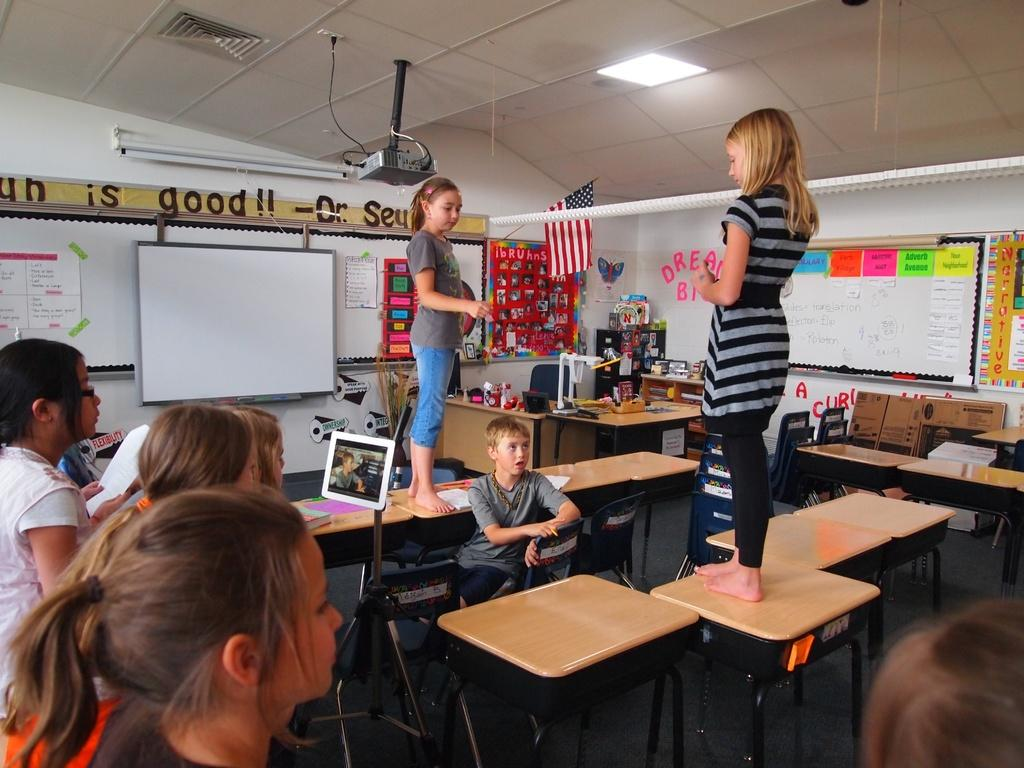What are the two girls doing in the image? The two girls are standing on a table in the image. Are there any other people present in the image? Yes, there are other people watching the girls in the image. What can be seen in the background of the image? There is a flag, a projector, a white screen, and a light in the image. What type of sign can be seen hanging from the ceiling in the image? There is no sign hanging from the ceiling in the image. How does the acoustics of the room affect the girls' performance in the image? The provided facts do not mention anything about the acoustics of the room, so it cannot be determined how it affects the girls' performance. Can you tell me how many pickles are on the table in the image? There are no pickles present in the image. 